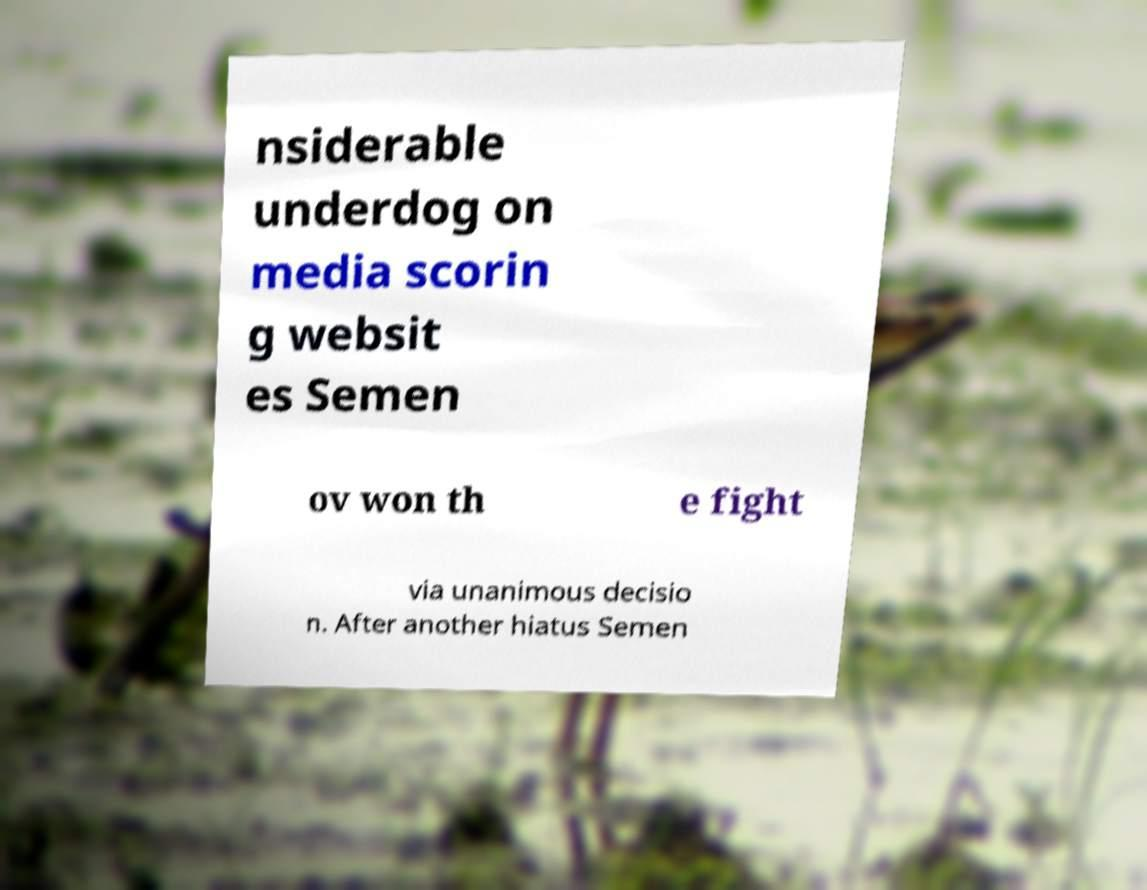I need the written content from this picture converted into text. Can you do that? nsiderable underdog on media scorin g websit es Semen ov won th e fight via unanimous decisio n. After another hiatus Semen 